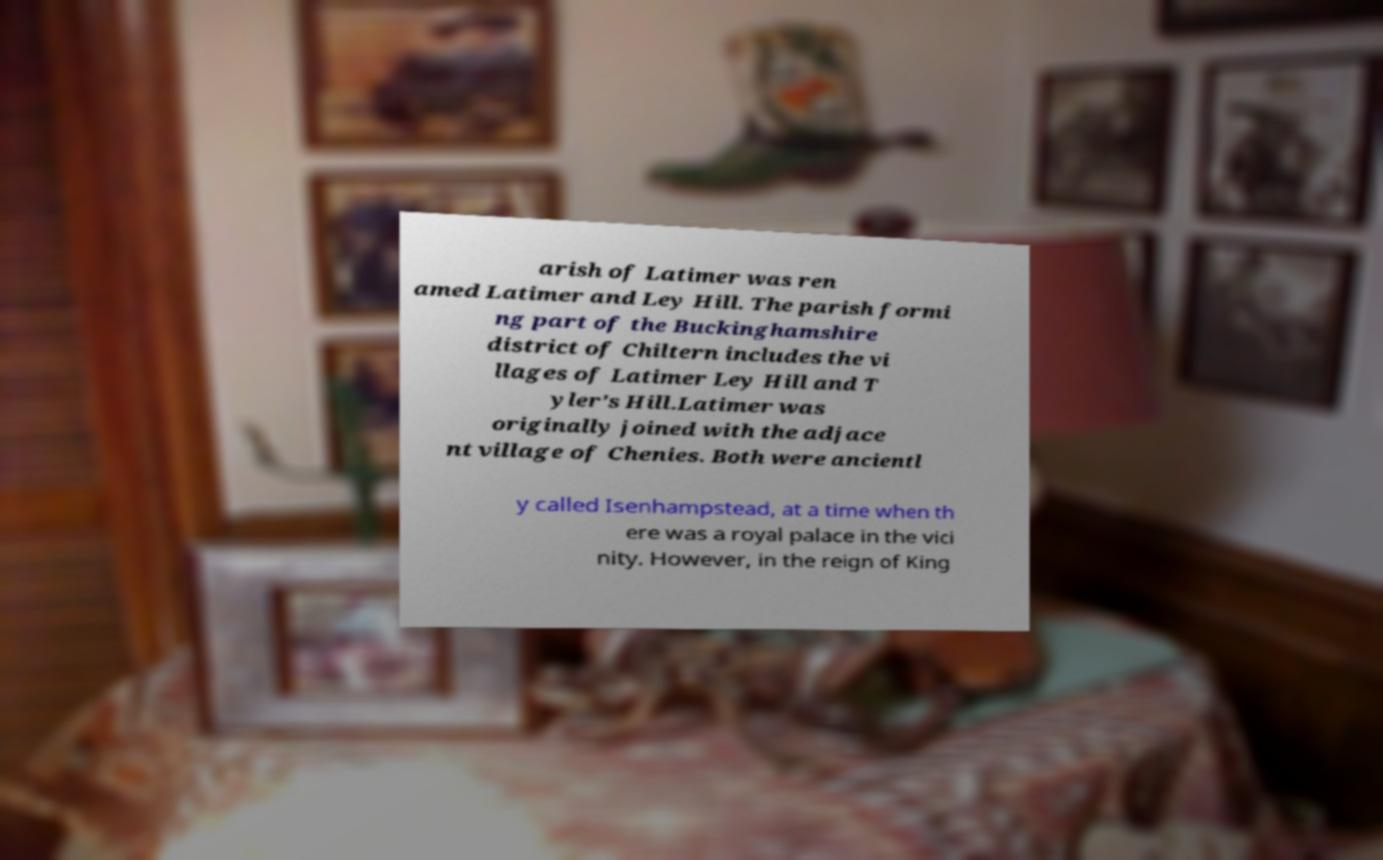What messages or text are displayed in this image? I need them in a readable, typed format. arish of Latimer was ren amed Latimer and Ley Hill. The parish formi ng part of the Buckinghamshire district of Chiltern includes the vi llages of Latimer Ley Hill and T yler's Hill.Latimer was originally joined with the adjace nt village of Chenies. Both were ancientl y called Isenhampstead, at a time when th ere was a royal palace in the vici nity. However, in the reign of King 